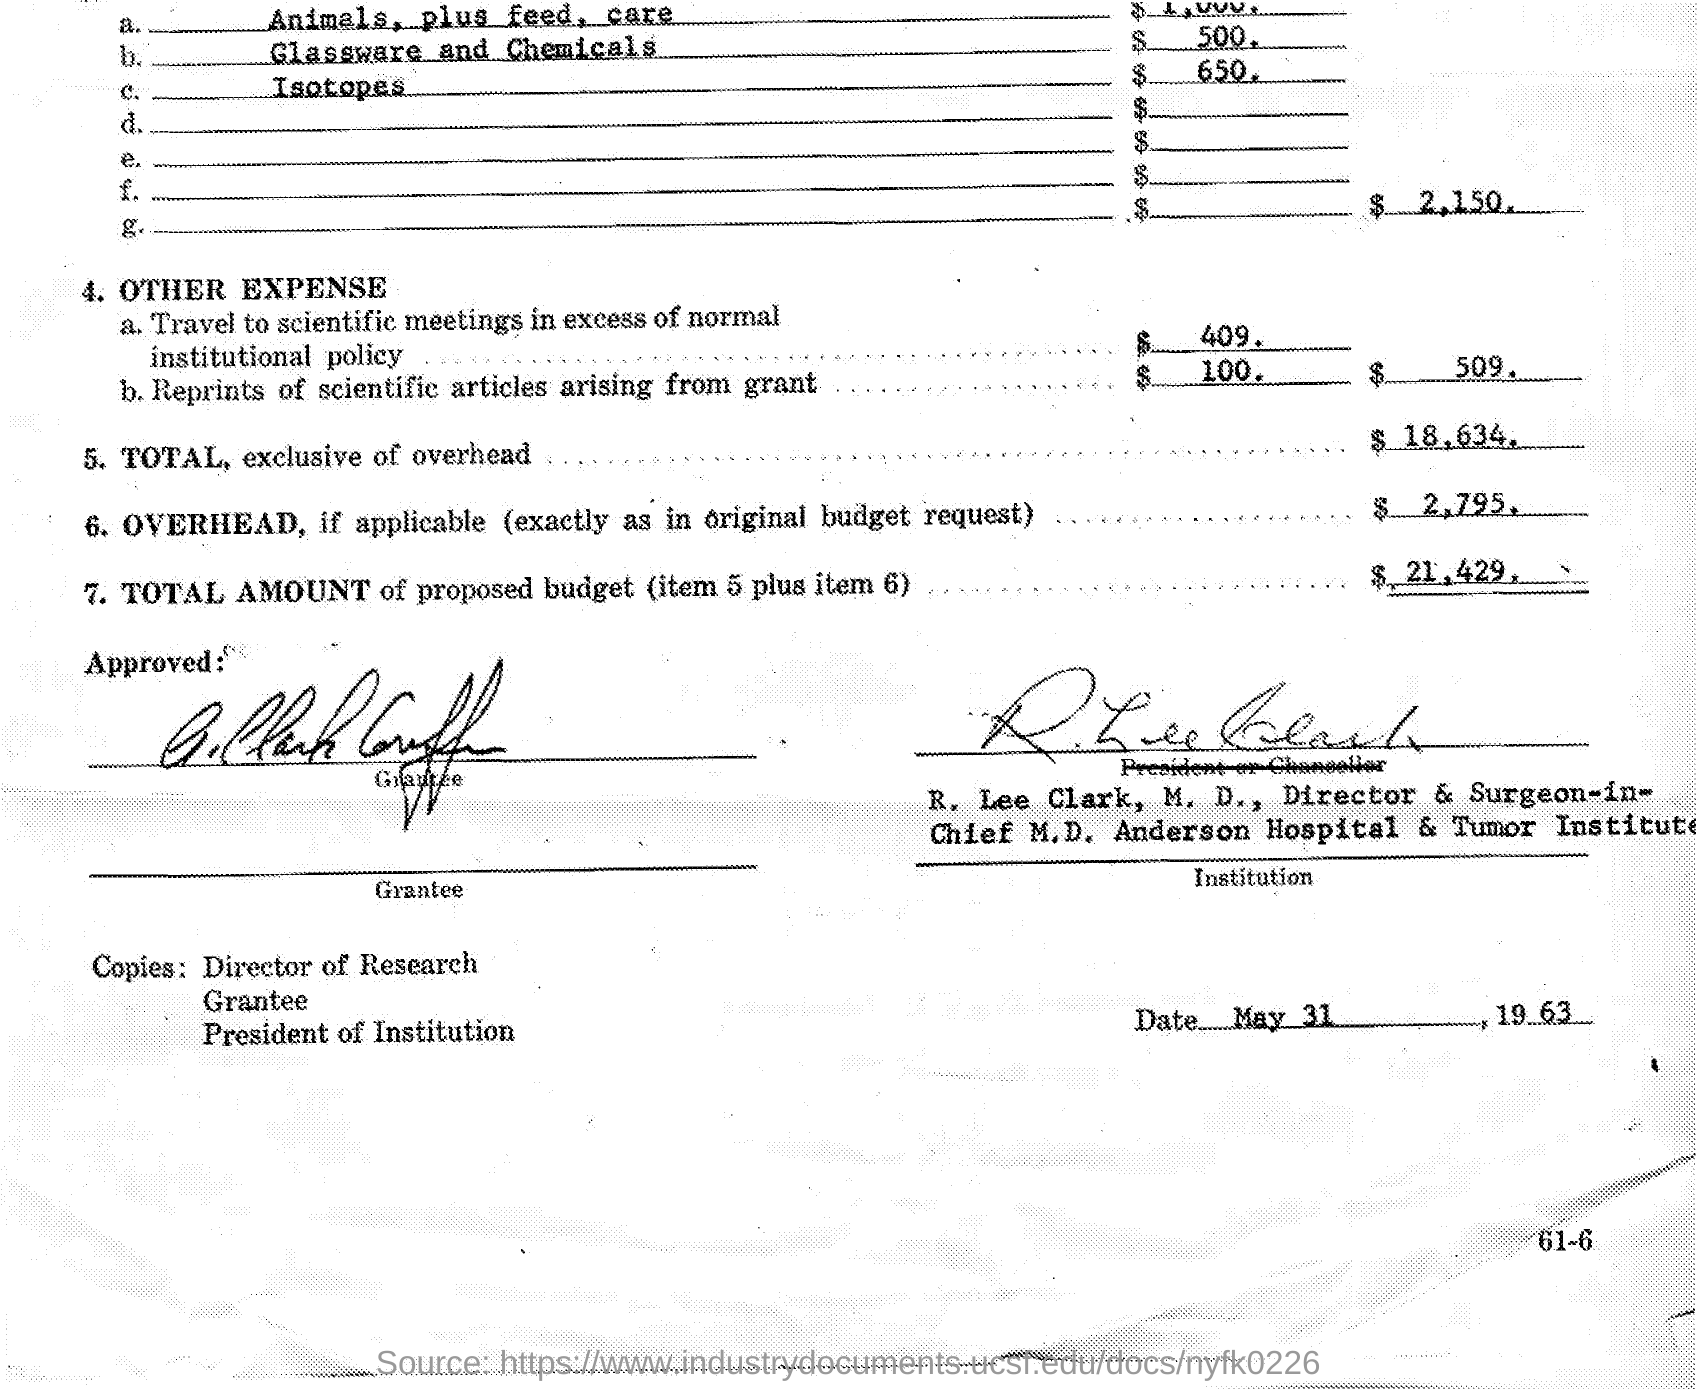Mention a couple of crucial points in this snapshot. Anderson Hospital & Tumor Institute is mentioned in the text. The document is dated May 31, 1963. 